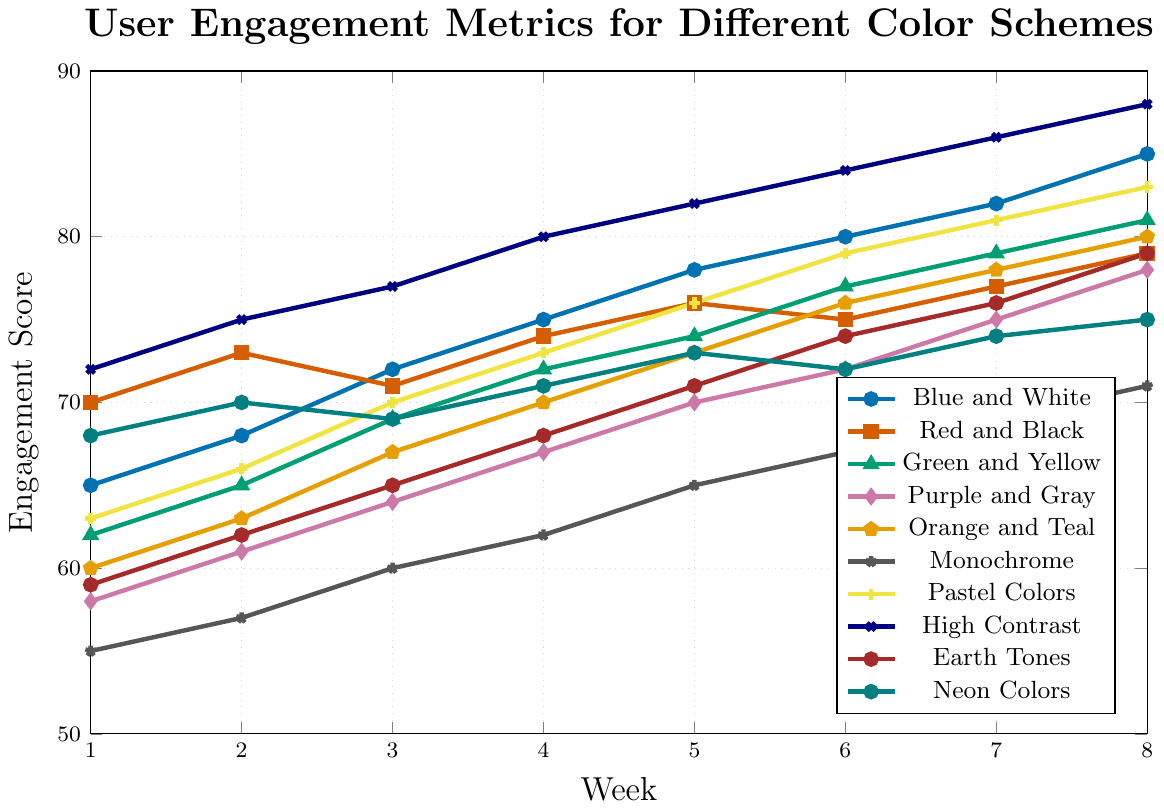How did the "Blue and White" scheme perform in comparison to the "Red and Black" scheme in Week 5? In Week 5, the "Blue and White" scheme had an engagement score of 78, while "Red and Black" had a score of 76.
Answer: "Blue and White" performed better Which color scheme showed the highest engagement score in Week 8? In Week 8, the "High Contrast" scheme showed the highest engagement score, reaching 88.
Answer: "High Contrast" What is the average engagement score for the "Pastel Colors" scheme over the 8 weeks? Sum of the weekly scores for "Pastel Colors" is: 63 + 66 + 70 + 73 + 76 + 79 + 81 + 83 = 591. The average is 591/8 = 73.875.
Answer: 73.875 Which two color schemes had a crossover point where one overtook the other in engagement score during any week? "Red and Black" and "Green and Yellow" intersected between Week 2 and Week 3. "Red and Black" had a higher score in Week 2 (73 vs. 65) but a lower one in Week 3 (71 vs. 69).
Answer: "Red and Black" and "Green and Yellow" In Week 6, which color schemes had engagement metrics below 70? In Week 6, the color schemes with engagement scores below 70 were "Purple and Gray" (72), "Monochrome" (67), and "Earth Tones" (74).
Answer: "Purple and Gray" and "Monochrome" and "Earth Tones" Across all 8 weeks, which color scheme showed the most improvement in engagement scores? The "High Contrast" scheme showed the most improvement, going from 72 in Week 1 to 88 in Week 8, an overall increase of 16 points.
Answer: "High Contrast" What is the total sum of engagement scores from Week 1 to Week 8 for the "Monochrome" scheme? Sum of the weekly scores for "Monochrome" from Week 1 to Week 8 is: 55 + 57 + 60 + 62 + 65 + 67 + 69 + 71 = 506.
Answer: 506 Between "Neon Colors" and "Purple and Gray", which had more consistent engagement scores (least variation) over the 8 weeks? To determine consistency, compare the range (max - min) of scores. "Neon Colors" range: 75 - 68 = 7, "Purple and Gray" range: 78 - 58 = 20. "Neon Colors" had less variation.
Answer: "Neon Colors" How did the "Green and Yellow" scheme trend over the 8 weeks? The "Green and Yellow" scheme showed a consistent upward trend from Week 1 (62) to Week 8 (81) with no decreases in engagement score.
Answer: Upward trend Which color scheme showed a dip in engagement in Week 3 compared to Week 2? The "Red and Black" scheme had an engagement score in Week 2 of 73 and dipped to 71 in Week 3.
Answer: "Red and Black" 